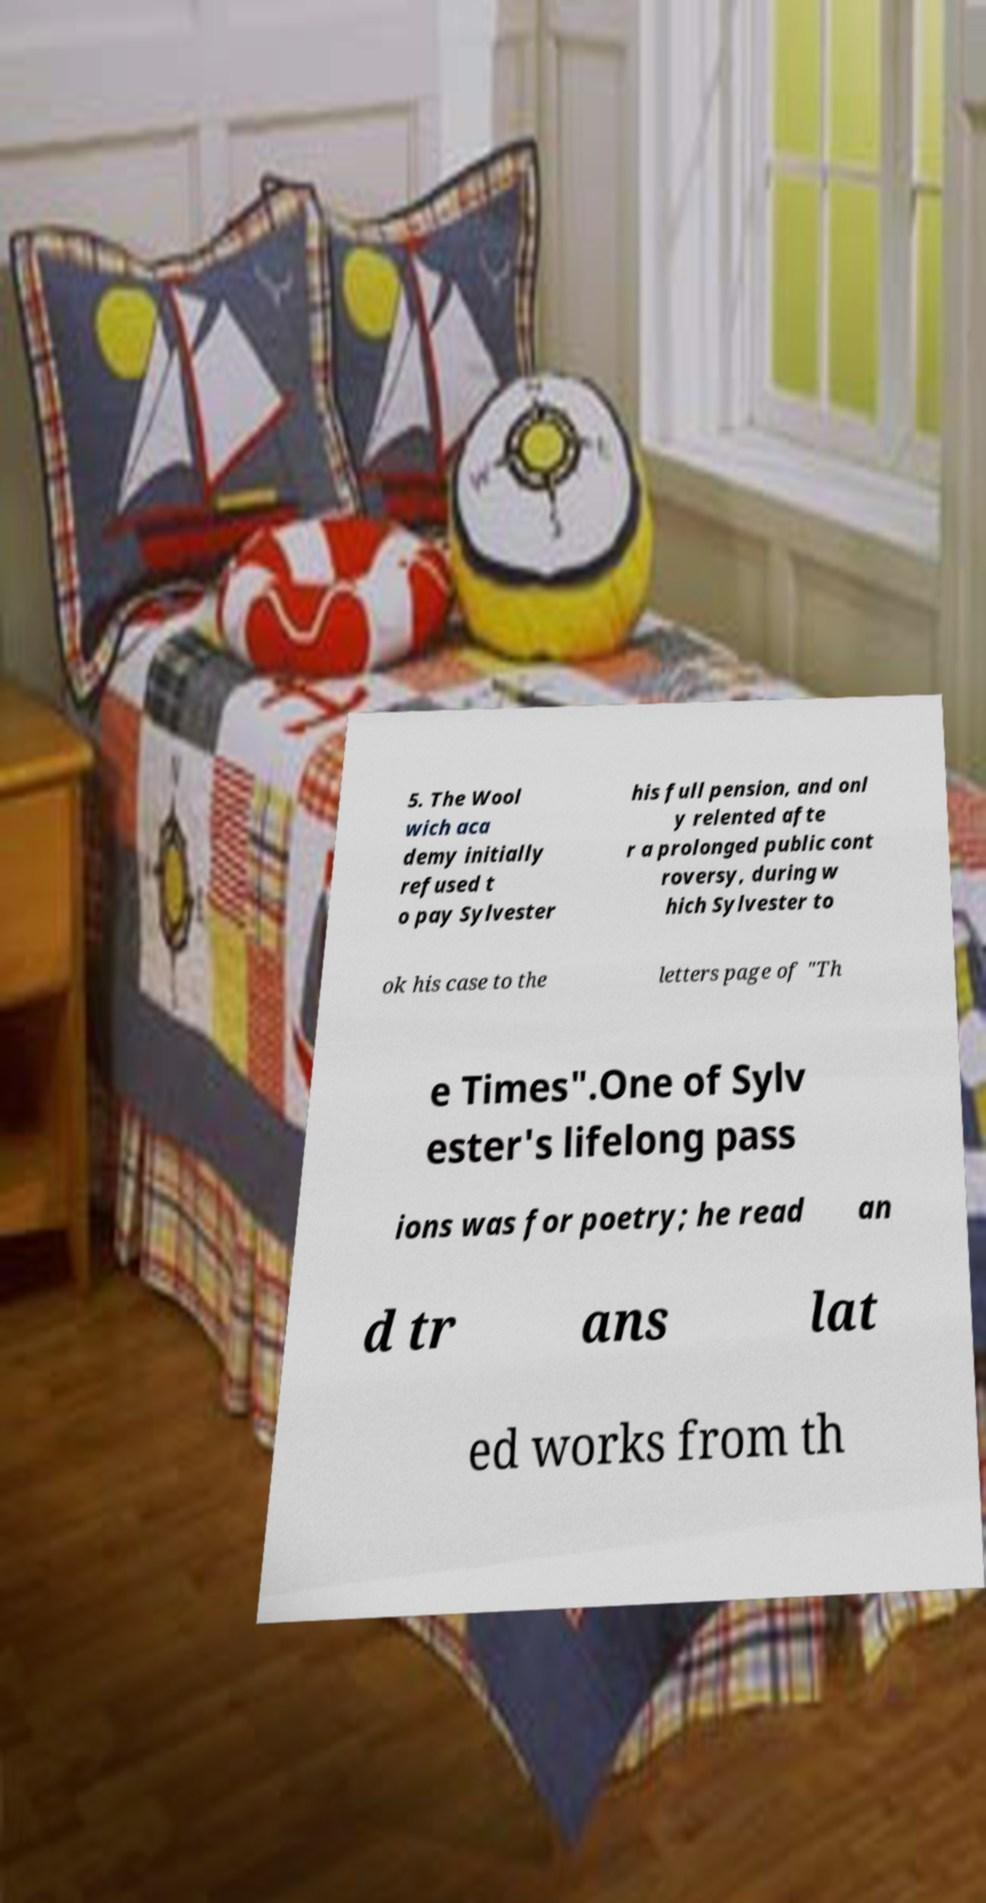Could you assist in decoding the text presented in this image and type it out clearly? 5. The Wool wich aca demy initially refused t o pay Sylvester his full pension, and onl y relented afte r a prolonged public cont roversy, during w hich Sylvester to ok his case to the letters page of "Th e Times".One of Sylv ester's lifelong pass ions was for poetry; he read an d tr ans lat ed works from th 